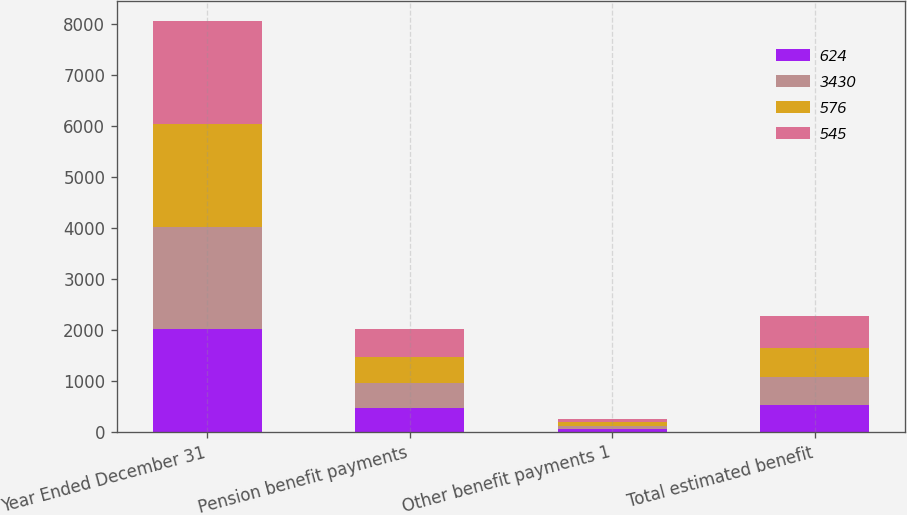Convert chart. <chart><loc_0><loc_0><loc_500><loc_500><stacked_bar_chart><ecel><fcel>Year Ended December 31<fcel>Pension benefit payments<fcel>Other benefit payments 1<fcel>Total estimated benefit<nl><fcel>624<fcel>2014<fcel>471<fcel>59<fcel>530<nl><fcel>3430<fcel>2015<fcel>483<fcel>62<fcel>545<nl><fcel>576<fcel>2016<fcel>512<fcel>64<fcel>576<nl><fcel>545<fcel>2017<fcel>554<fcel>65<fcel>619<nl></chart> 